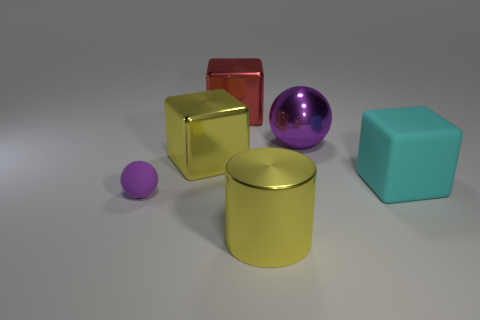Add 2 big cyan blocks. How many objects exist? 8 Subtract all balls. How many objects are left? 4 Add 6 rubber things. How many rubber things are left? 8 Add 3 purple matte cubes. How many purple matte cubes exist? 3 Subtract 0 cyan spheres. How many objects are left? 6 Subtract all cyan things. Subtract all cyan rubber blocks. How many objects are left? 4 